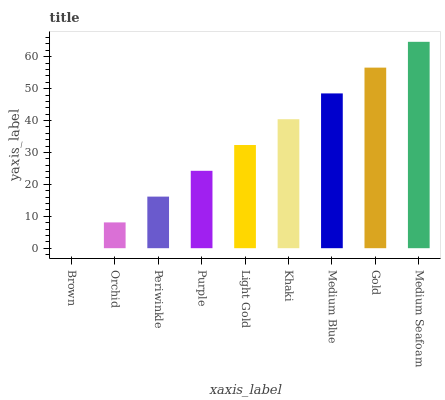Is Brown the minimum?
Answer yes or no. Yes. Is Medium Seafoam the maximum?
Answer yes or no. Yes. Is Orchid the minimum?
Answer yes or no. No. Is Orchid the maximum?
Answer yes or no. No. Is Orchid greater than Brown?
Answer yes or no. Yes. Is Brown less than Orchid?
Answer yes or no. Yes. Is Brown greater than Orchid?
Answer yes or no. No. Is Orchid less than Brown?
Answer yes or no. No. Is Light Gold the high median?
Answer yes or no. Yes. Is Light Gold the low median?
Answer yes or no. Yes. Is Khaki the high median?
Answer yes or no. No. Is Medium Seafoam the low median?
Answer yes or no. No. 